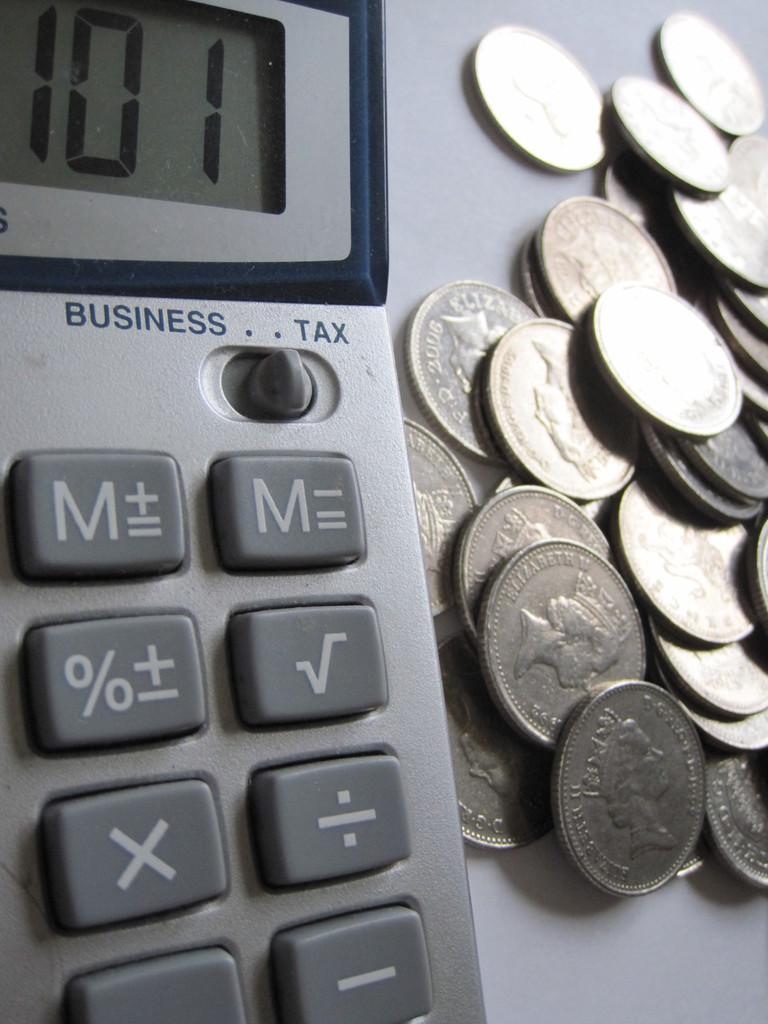What number is displayed on the calculator?
Make the answer very short. 101. What do the words say near the top right of the calculator?
Offer a very short reply. Tax. 